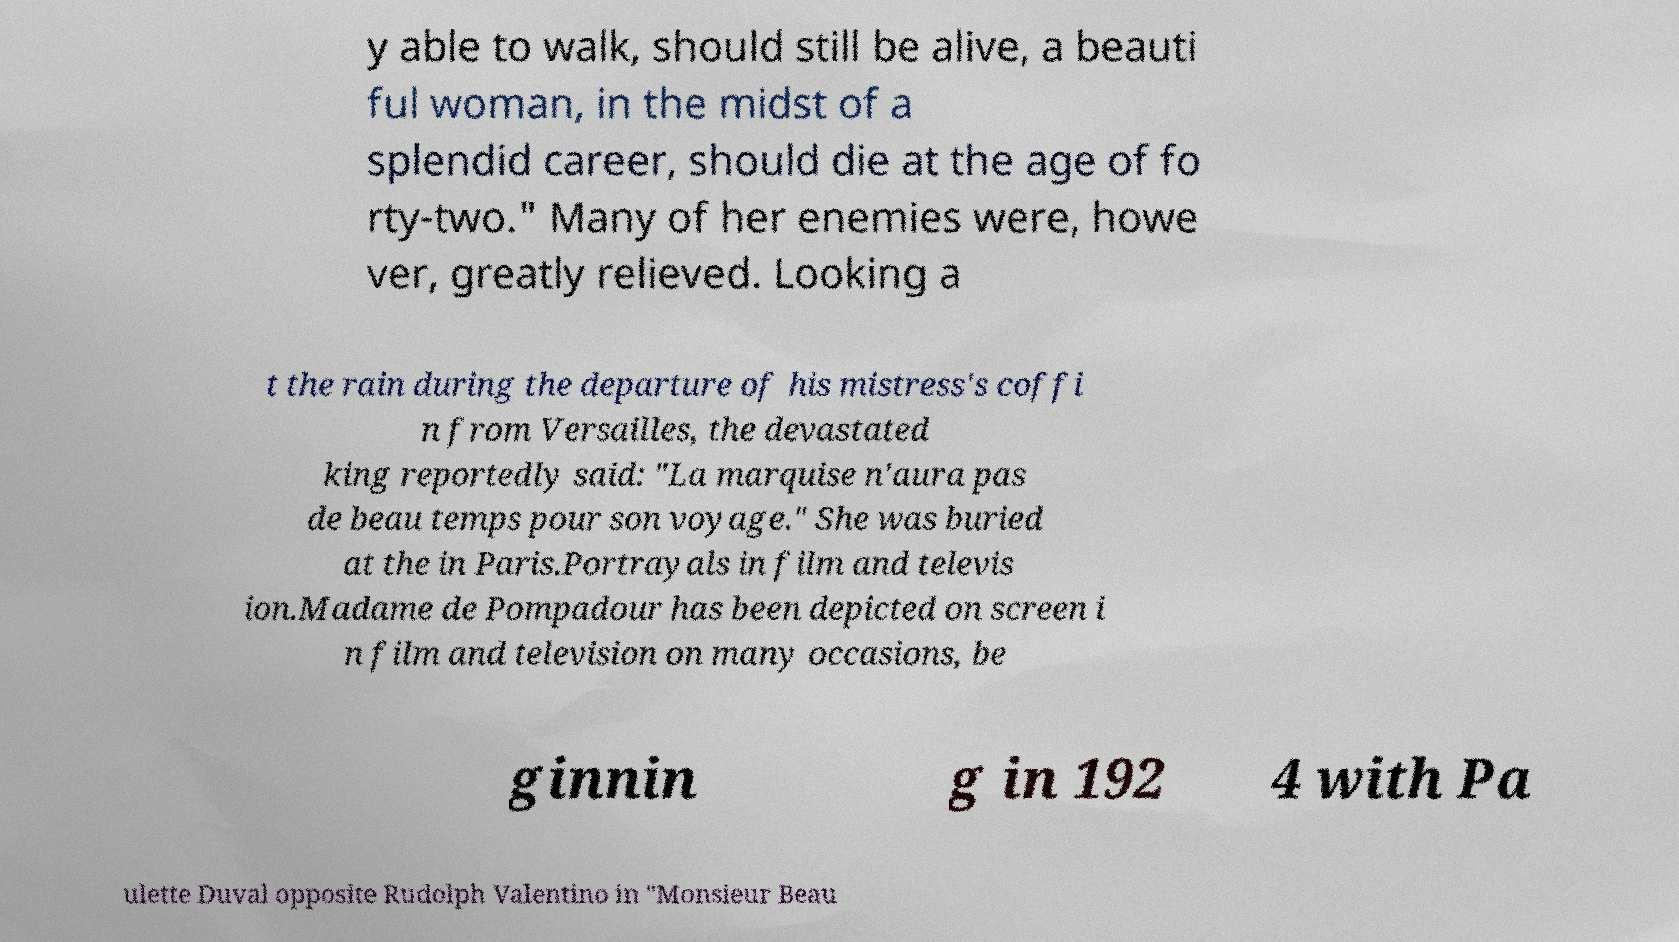Could you extract and type out the text from this image? y able to walk, should still be alive, a beauti ful woman, in the midst of a splendid career, should die at the age of fo rty-two." Many of her enemies were, howe ver, greatly relieved. Looking a t the rain during the departure of his mistress's coffi n from Versailles, the devastated king reportedly said: "La marquise n'aura pas de beau temps pour son voyage." She was buried at the in Paris.Portrayals in film and televis ion.Madame de Pompadour has been depicted on screen i n film and television on many occasions, be ginnin g in 192 4 with Pa ulette Duval opposite Rudolph Valentino in "Monsieur Beau 